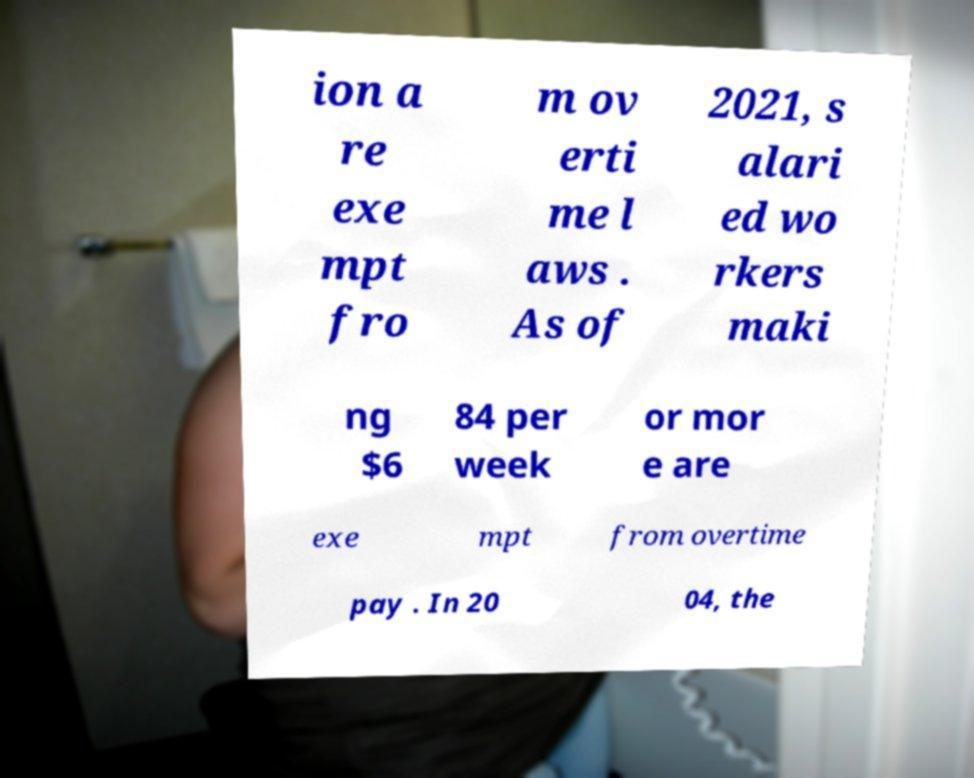There's text embedded in this image that I need extracted. Can you transcribe it verbatim? ion a re exe mpt fro m ov erti me l aws . As of 2021, s alari ed wo rkers maki ng $6 84 per week or mor e are exe mpt from overtime pay . In 20 04, the 